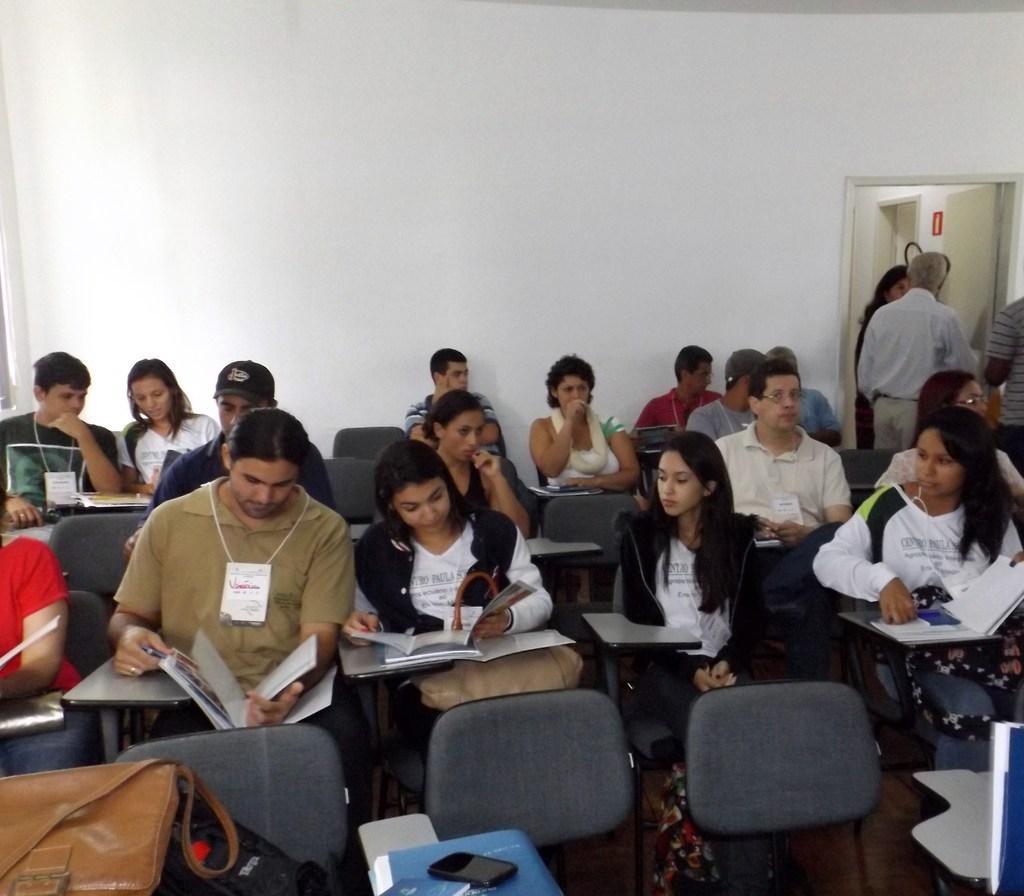Please provide a concise description of this image. In this image I can see a group of people are sitting on the chairs and are holding books in their hand. In the background I can see a wall, door and four persons are standing. This image is taken, may be in a hall. 